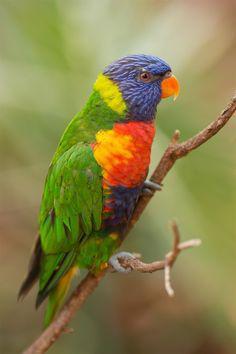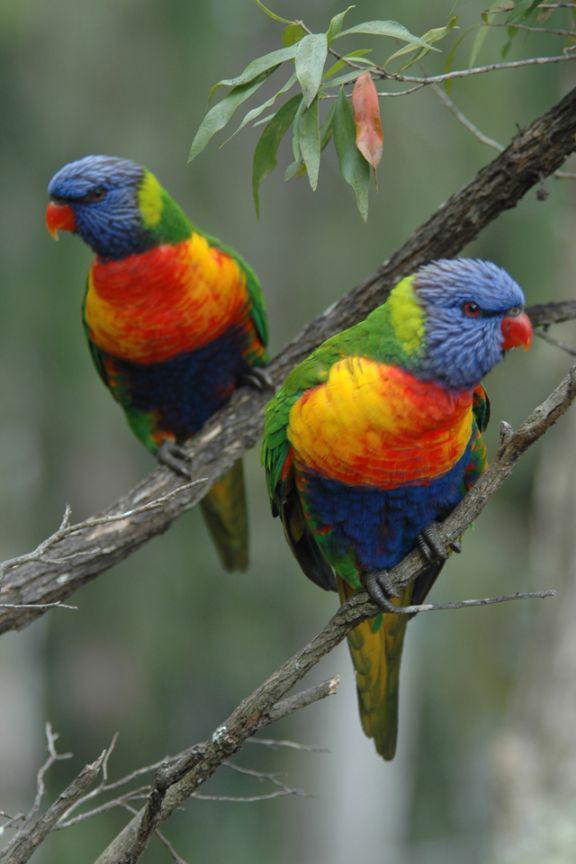The first image is the image on the left, the second image is the image on the right. Assess this claim about the two images: "At least one image shows a group of parrots around some kind of round container for food or drink.". Correct or not? Answer yes or no. No. 